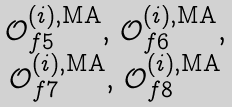Convert formula to latex. <formula><loc_0><loc_0><loc_500><loc_500>\begin{matrix} \mathcal { O } ^ { ( i ) , \text {MA} } _ { f 5 } , \, \mathcal { O } ^ { ( i ) , \text {MA} } _ { f 6 } , \\ \mathcal { O } ^ { ( i ) , \text {MA} } _ { f 7 } , \, \mathcal { O } ^ { ( i ) , \text {MA} } _ { f 8 } \end{matrix}</formula> 